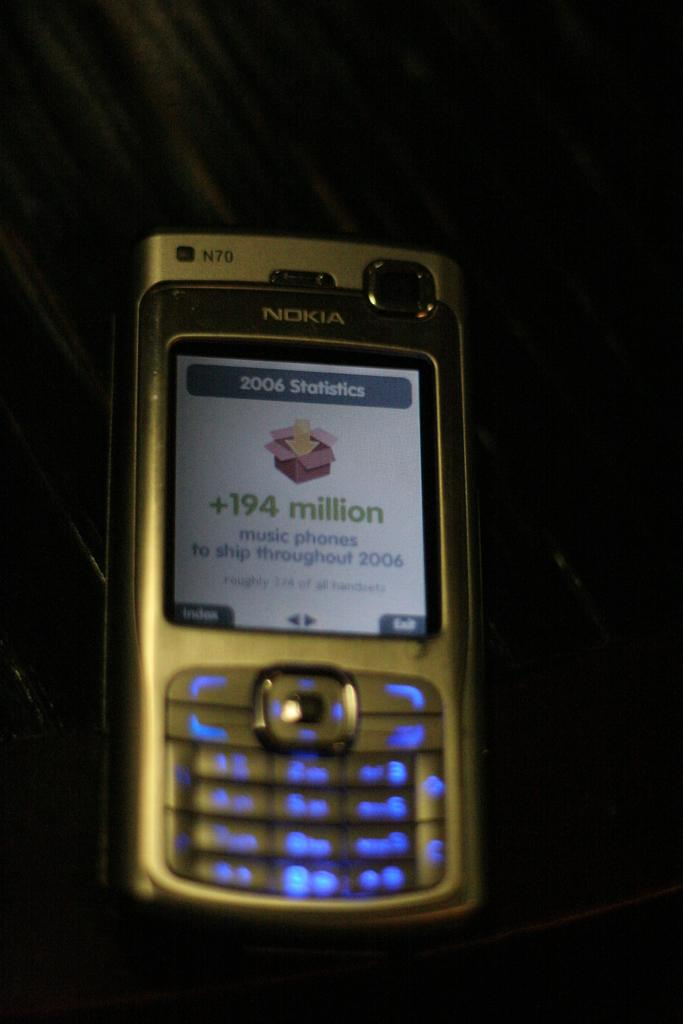Provide a one-sentence caption for the provided image. A Nokia phone with a 2006 Statistics screen pulled up. 